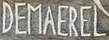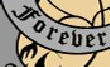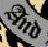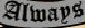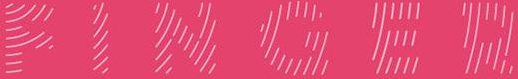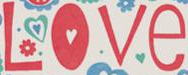Transcribe the words shown in these images in order, separated by a semicolon. DEMAEREL; Forever; And; Always; FINGER; Love 